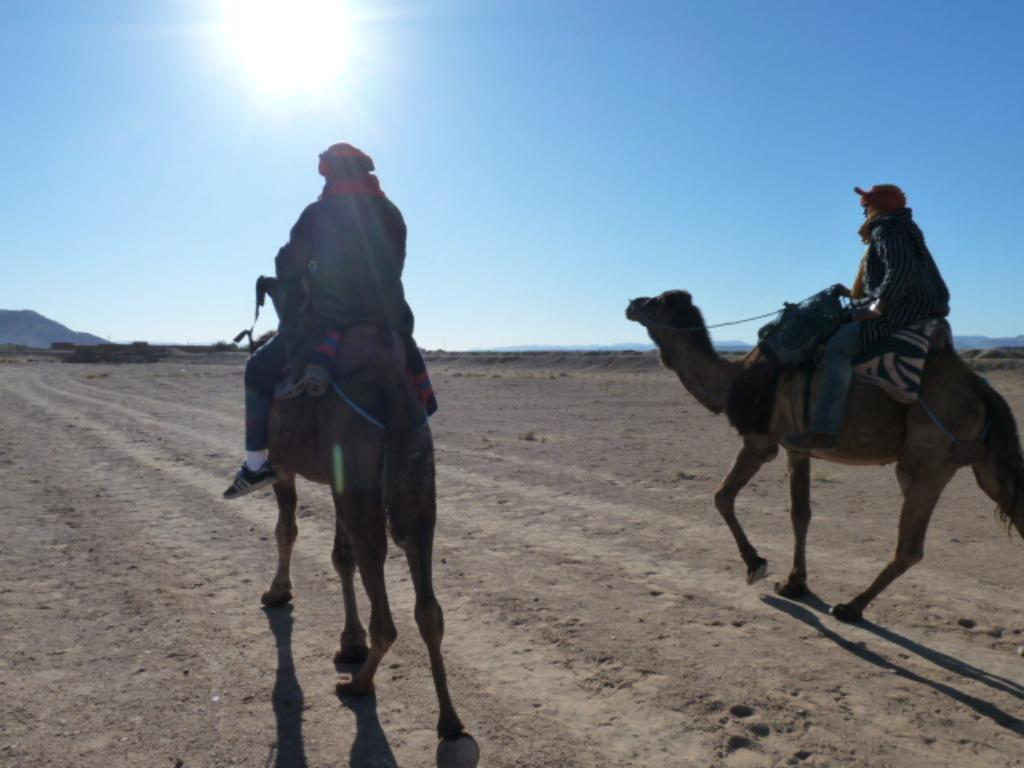How many people are in the image? There are two men in the image. What are the men doing in the image? The men are riding a camel in the image. What is the location of the scene in the image? The setting is in a desert. What can be seen in the background of the image? There is a hilly area in the background of the image. What type of lettuce is growing in the desert in the image? There is no lettuce present in the image; the setting is in a desert, and the focus is on the men riding a camel. 